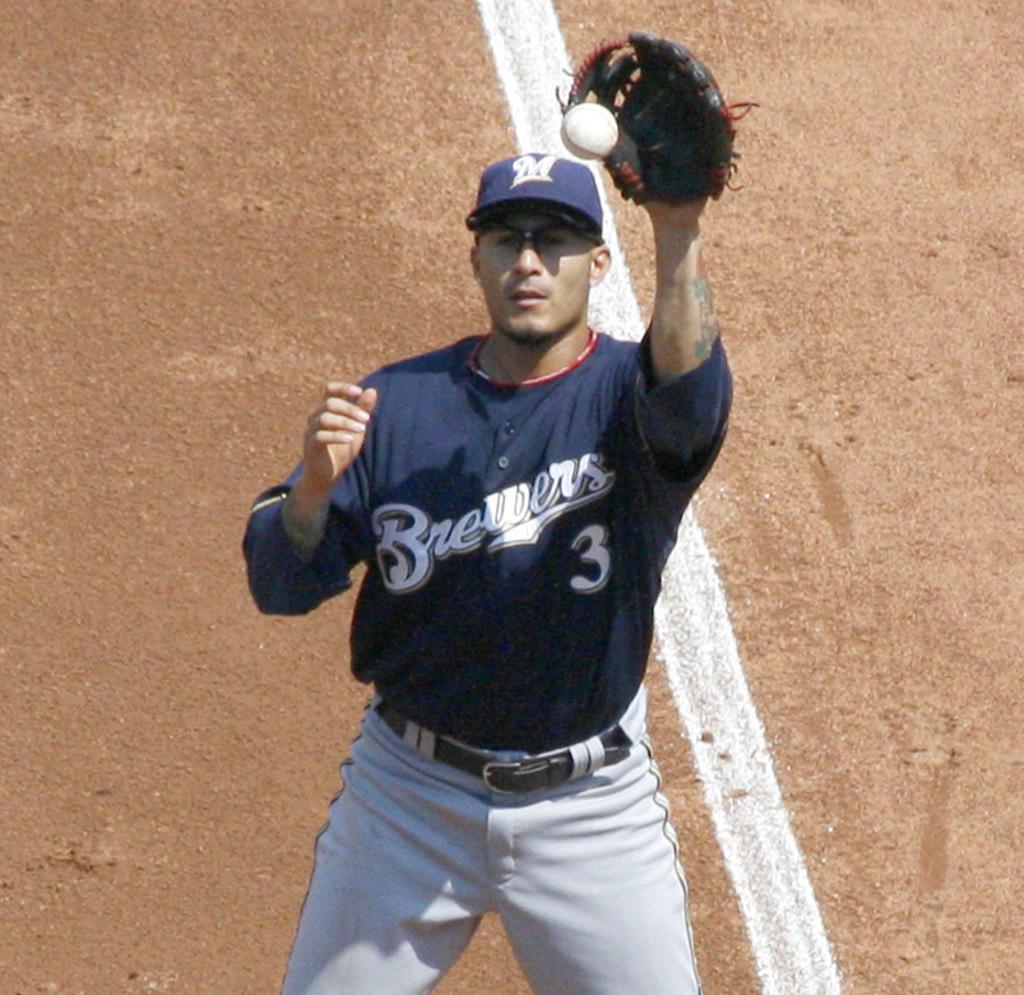What number is the catcher?
Keep it short and to the point. 3. 